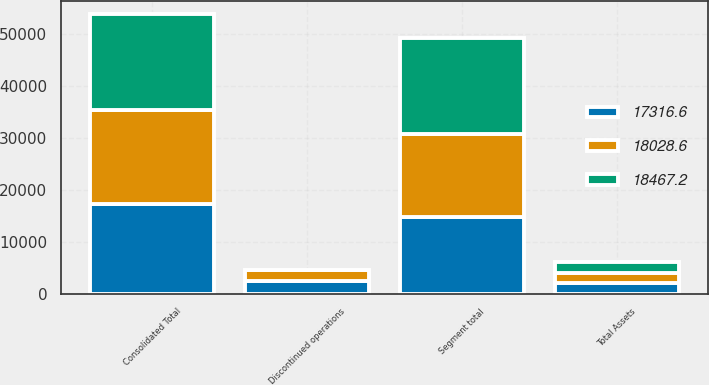Convert chart. <chart><loc_0><loc_0><loc_500><loc_500><stacked_bar_chart><ecel><fcel>Total Assets<fcel>Segment total<fcel>Discontinued operations<fcel>Consolidated Total<nl><fcel>18467.2<fcel>2017<fcel>18457<fcel>10.2<fcel>18467.2<nl><fcel>18028.6<fcel>2016<fcel>16060.1<fcel>1968.5<fcel>18028.6<nl><fcel>17316.6<fcel>2015<fcel>14760<fcel>2556.6<fcel>17316.6<nl></chart> 